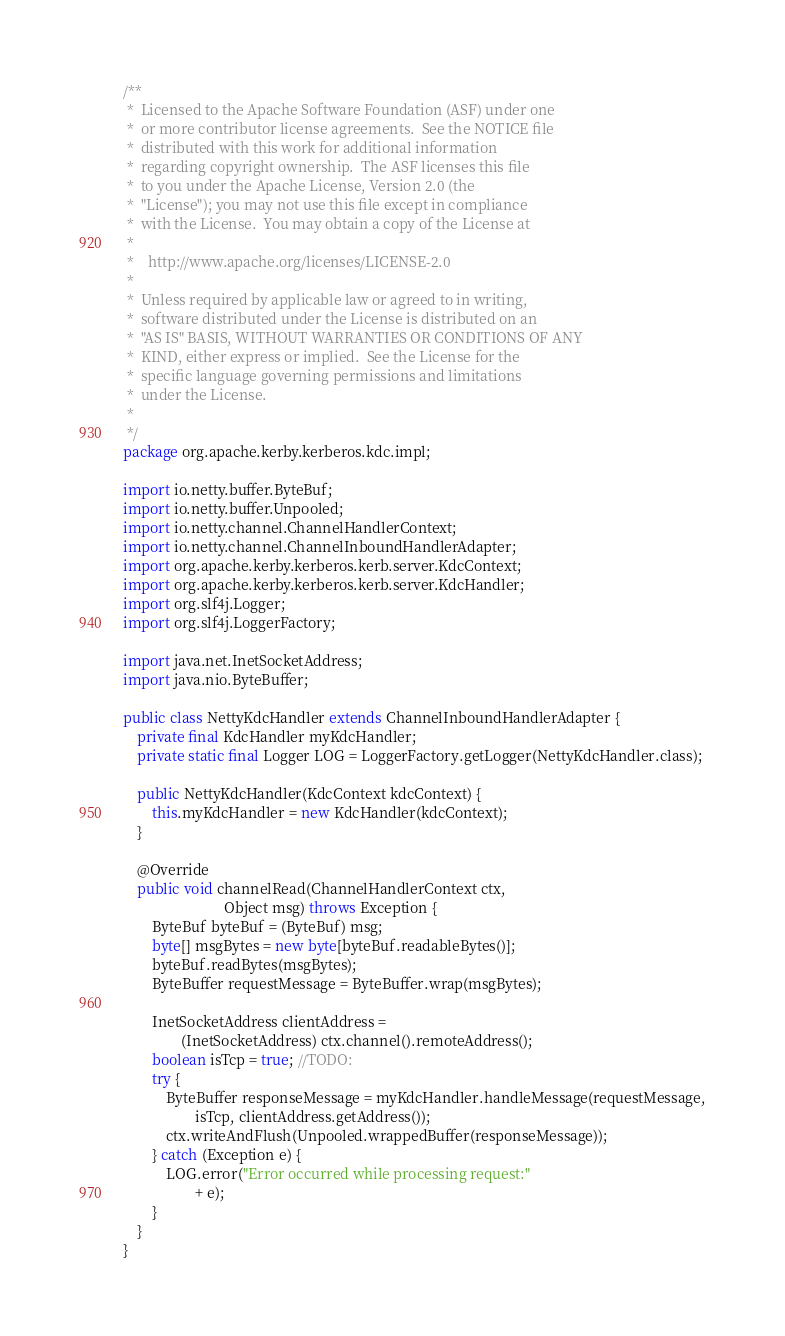Convert code to text. <code><loc_0><loc_0><loc_500><loc_500><_Java_>/**
 *  Licensed to the Apache Software Foundation (ASF) under one
 *  or more contributor license agreements.  See the NOTICE file
 *  distributed with this work for additional information
 *  regarding copyright ownership.  The ASF licenses this file
 *  to you under the Apache License, Version 2.0 (the
 *  "License"); you may not use this file except in compliance
 *  with the License.  You may obtain a copy of the License at
 *  
 *    http://www.apache.org/licenses/LICENSE-2.0
 *  
 *  Unless required by applicable law or agreed to in writing,
 *  software distributed under the License is distributed on an
 *  "AS IS" BASIS, WITHOUT WARRANTIES OR CONDITIONS OF ANY
 *  KIND, either express or implied.  See the License for the
 *  specific language governing permissions and limitations
 *  under the License. 
 *  
 */
package org.apache.kerby.kerberos.kdc.impl;

import io.netty.buffer.ByteBuf;
import io.netty.buffer.Unpooled;
import io.netty.channel.ChannelHandlerContext;
import io.netty.channel.ChannelInboundHandlerAdapter;
import org.apache.kerby.kerberos.kerb.server.KdcContext;
import org.apache.kerby.kerberos.kerb.server.KdcHandler;
import org.slf4j.Logger;
import org.slf4j.LoggerFactory;

import java.net.InetSocketAddress;
import java.nio.ByteBuffer;

public class NettyKdcHandler extends ChannelInboundHandlerAdapter {
    private final KdcHandler myKdcHandler;
    private static final Logger LOG = LoggerFactory.getLogger(NettyKdcHandler.class);

    public NettyKdcHandler(KdcContext kdcContext) {
        this.myKdcHandler = new KdcHandler(kdcContext);
    }

    @Override
    public void channelRead(ChannelHandlerContext ctx,
                            Object msg) throws Exception {
        ByteBuf byteBuf = (ByteBuf) msg;
        byte[] msgBytes = new byte[byteBuf.readableBytes()];
        byteBuf.readBytes(msgBytes);
        ByteBuffer requestMessage = ByteBuffer.wrap(msgBytes);

        InetSocketAddress clientAddress =
                (InetSocketAddress) ctx.channel().remoteAddress();
        boolean isTcp = true; //TODO:
        try {
            ByteBuffer responseMessage = myKdcHandler.handleMessage(requestMessage,
                    isTcp, clientAddress.getAddress());
            ctx.writeAndFlush(Unpooled.wrappedBuffer(responseMessage));
        } catch (Exception e) {
            LOG.error("Error occurred while processing request:"
                    + e);
        }
    }
}
</code> 